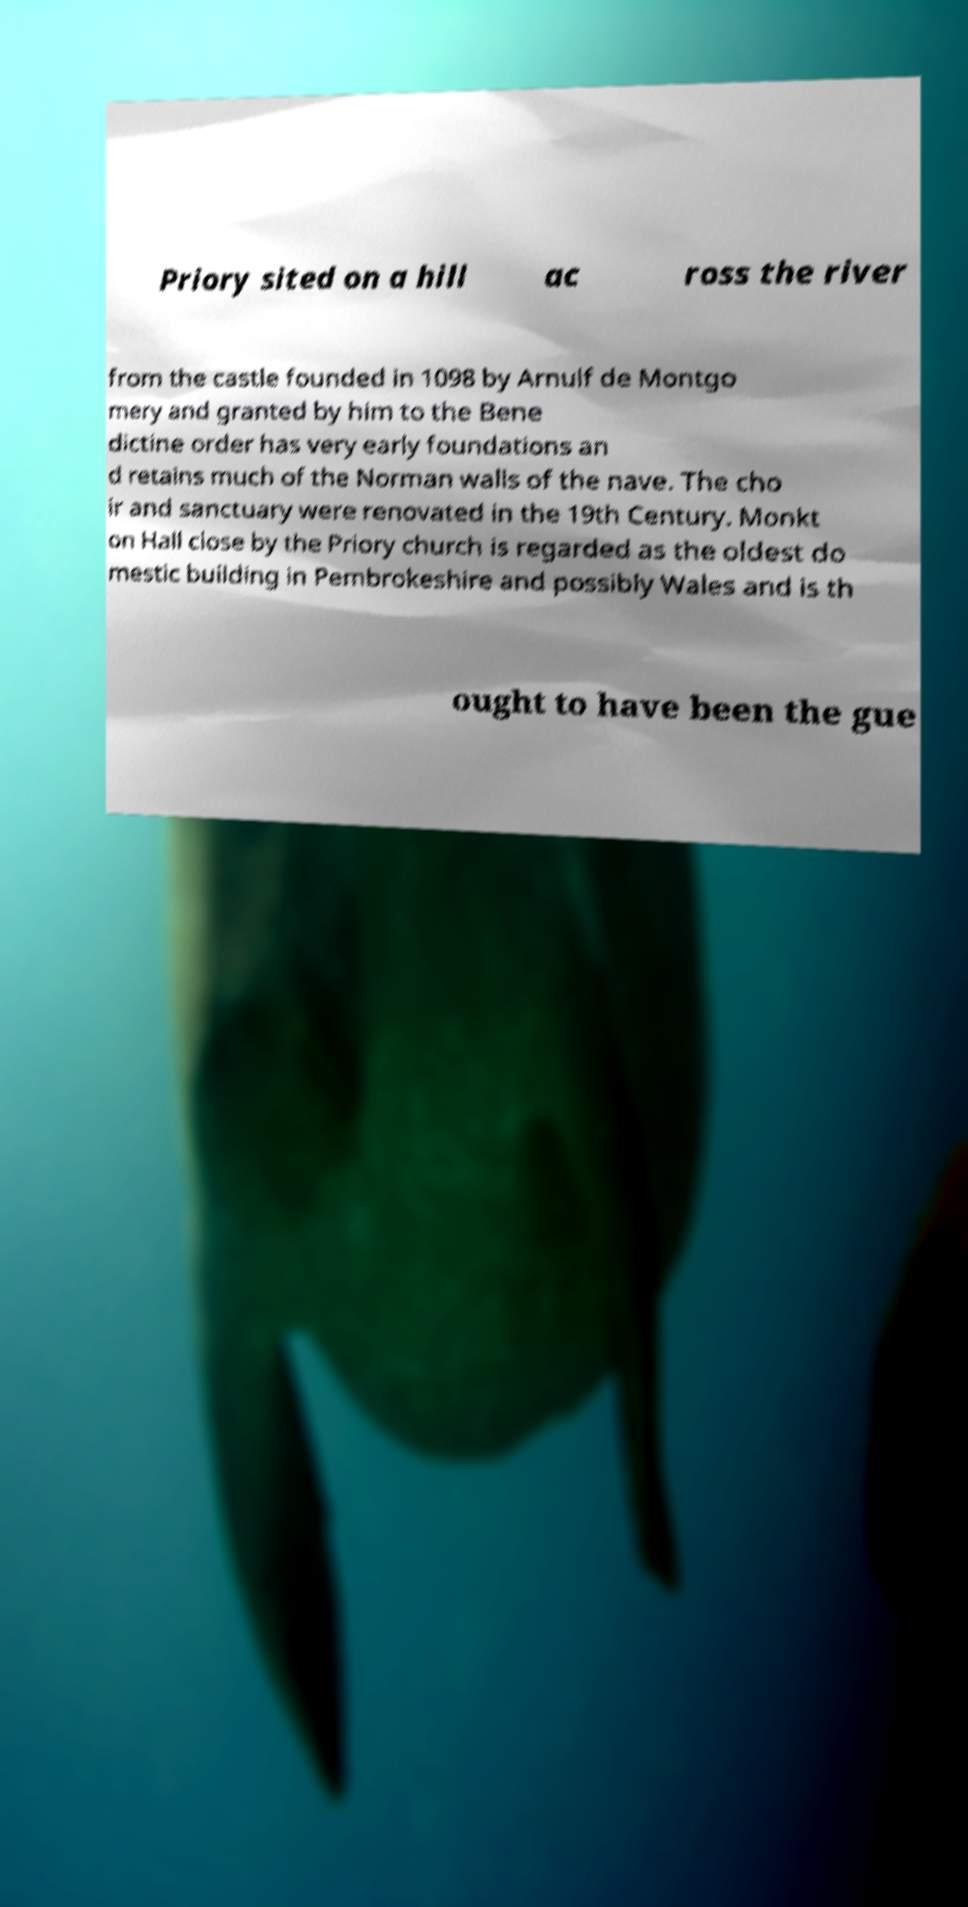Please identify and transcribe the text found in this image. Priory sited on a hill ac ross the river from the castle founded in 1098 by Arnulf de Montgo mery and granted by him to the Bene dictine order has very early foundations an d retains much of the Norman walls of the nave. The cho ir and sanctuary were renovated in the 19th Century. Monkt on Hall close by the Priory church is regarded as the oldest do mestic building in Pembrokeshire and possibly Wales and is th ought to have been the gue 